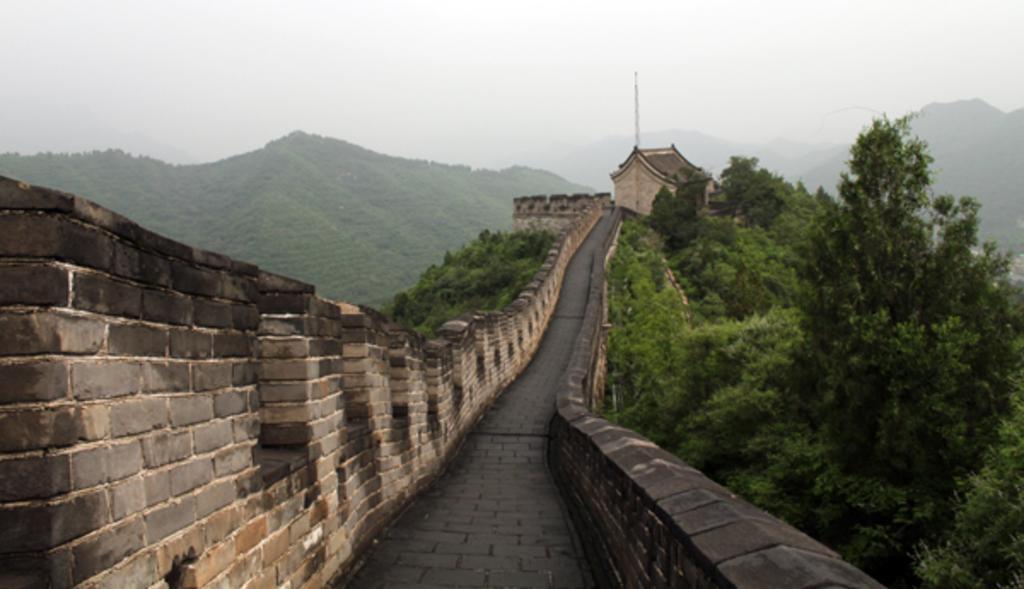Please provide a concise description of this image. In this picture I can observe a path. There are walls on either sides of this path. In the background there are trees on the hills. I can observe fog in this picture. 